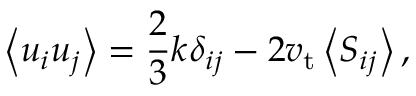Convert formula to latex. <formula><loc_0><loc_0><loc_500><loc_500>\left \langle u _ { i } u _ { j } \right \rangle = \frac { 2 } { 3 } k \delta _ { i j } - 2 v _ { t } \left \langle S _ { i j } \right \rangle ,</formula> 